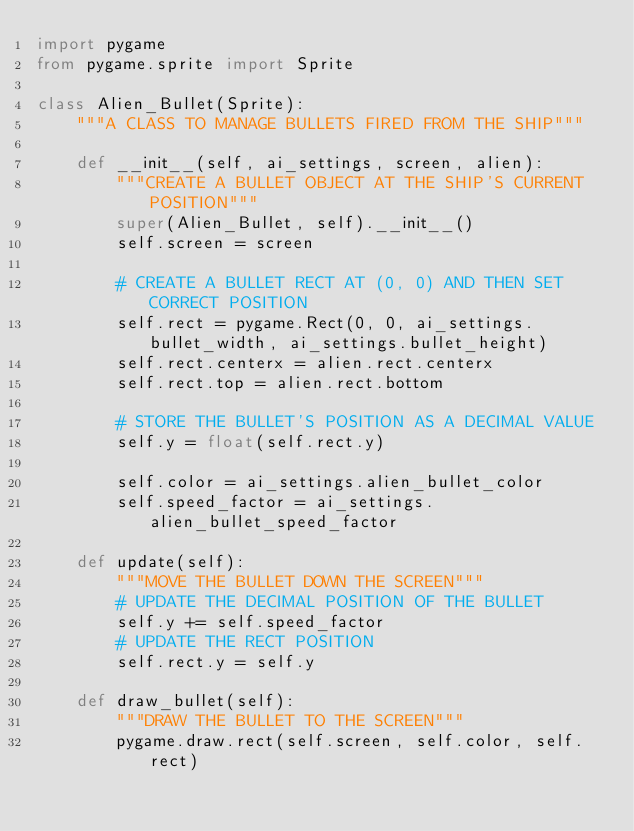Convert code to text. <code><loc_0><loc_0><loc_500><loc_500><_Python_>import pygame
from pygame.sprite import Sprite

class Alien_Bullet(Sprite):
    """A CLASS TO MANAGE BULLETS FIRED FROM THE SHIP"""

    def __init__(self, ai_settings, screen, alien):
        """CREATE A BULLET OBJECT AT THE SHIP'S CURRENT POSITION"""
        super(Alien_Bullet, self).__init__()
        self.screen = screen

        # CREATE A BULLET RECT AT (0, 0) AND THEN SET CORRECT POSITION
        self.rect = pygame.Rect(0, 0, ai_settings.bullet_width, ai_settings.bullet_height)
        self.rect.centerx = alien.rect.centerx
        self.rect.top = alien.rect.bottom
        
        # STORE THE BULLET'S POSITION AS A DECIMAL VALUE
        self.y = float(self.rect.y)

        self.color = ai_settings.alien_bullet_color
        self.speed_factor = ai_settings.alien_bullet_speed_factor
    
    def update(self):
        """MOVE THE BULLET DOWN THE SCREEN"""
        # UPDATE THE DECIMAL POSITION OF THE BULLET
        self.y += self.speed_factor
        # UPDATE THE RECT POSITION
        self.rect.y = self.y

    def draw_bullet(self):
        """DRAW THE BULLET TO THE SCREEN"""
        pygame.draw.rect(self.screen, self.color, self.rect)
        </code> 